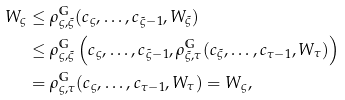Convert formula to latex. <formula><loc_0><loc_0><loc_500><loc_500>W _ { \varsigma } & \leq \rho ^ { \mathbb { G } } _ { \varsigma , \tilde { \varsigma } } ( c _ { \varsigma } , \dots , c _ { \tilde { \varsigma } - 1 } , W _ { \tilde { \varsigma } } ) \\ & \leq \rho ^ { \mathbb { G } } _ { \varsigma , \tilde { \varsigma } } \left ( c _ { \varsigma } , \dots , c _ { \tilde { \varsigma } - 1 } , \rho ^ { \mathbb { G } } _ { \tilde { \varsigma } , \tau } ( c _ { \tilde { \varsigma } } , \dots , c _ { \tau - 1 } , W _ { \tau } ) \right ) \\ & = \rho ^ { \mathbb { G } } _ { \varsigma , \tau } ( c _ { \varsigma } , \dots , c _ { \tau - 1 } , W _ { \tau } ) = W _ { \varsigma } ,</formula> 